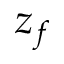<formula> <loc_0><loc_0><loc_500><loc_500>z _ { f }</formula> 